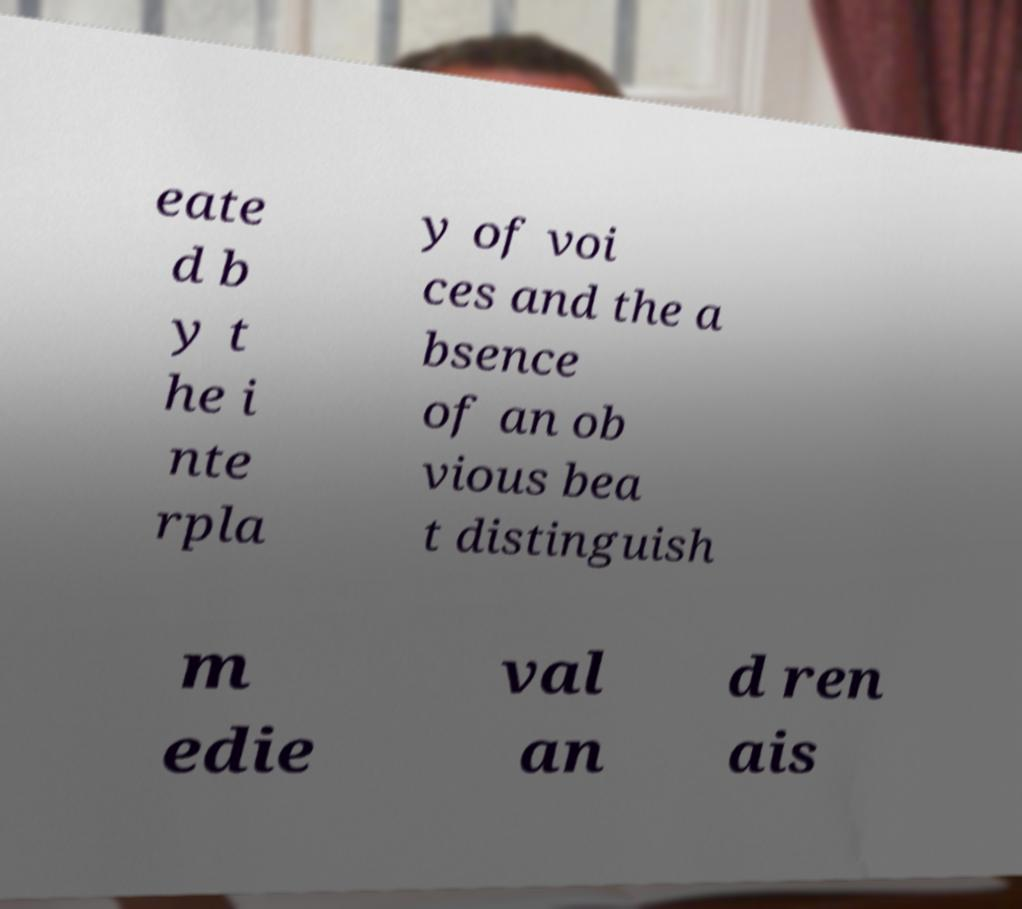Can you read and provide the text displayed in the image?This photo seems to have some interesting text. Can you extract and type it out for me? eate d b y t he i nte rpla y of voi ces and the a bsence of an ob vious bea t distinguish m edie val an d ren ais 